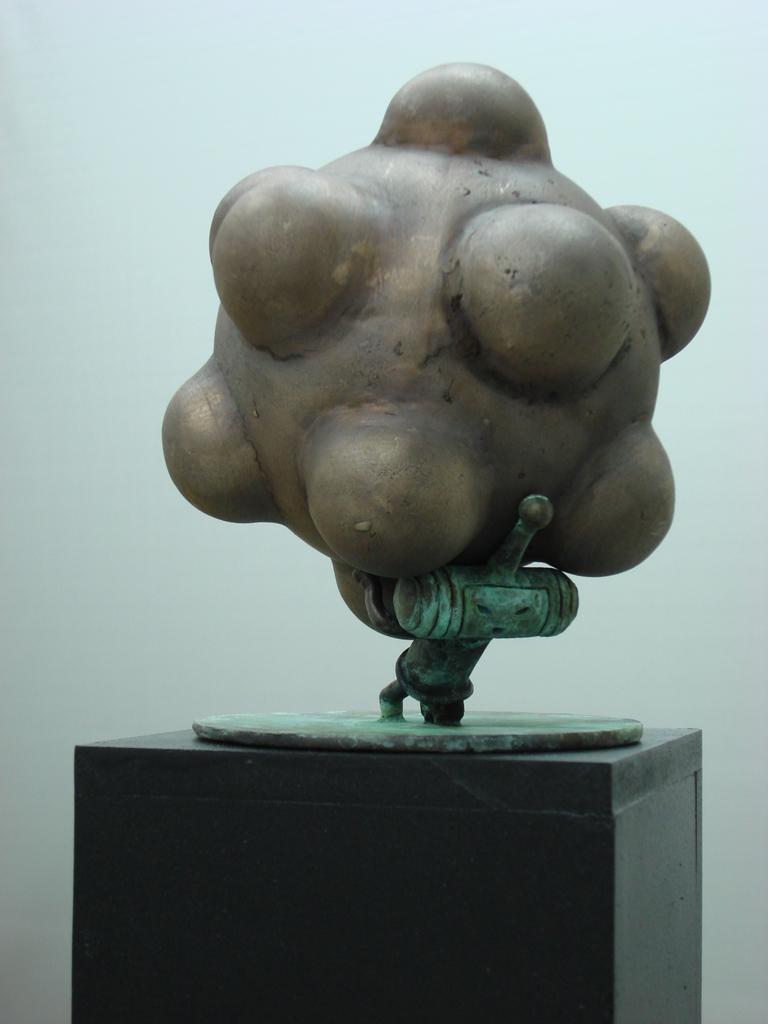Please provide a concise description of this image. In this picture there is a sculpture. At the bottom there is a table. At the back there is a wall. 